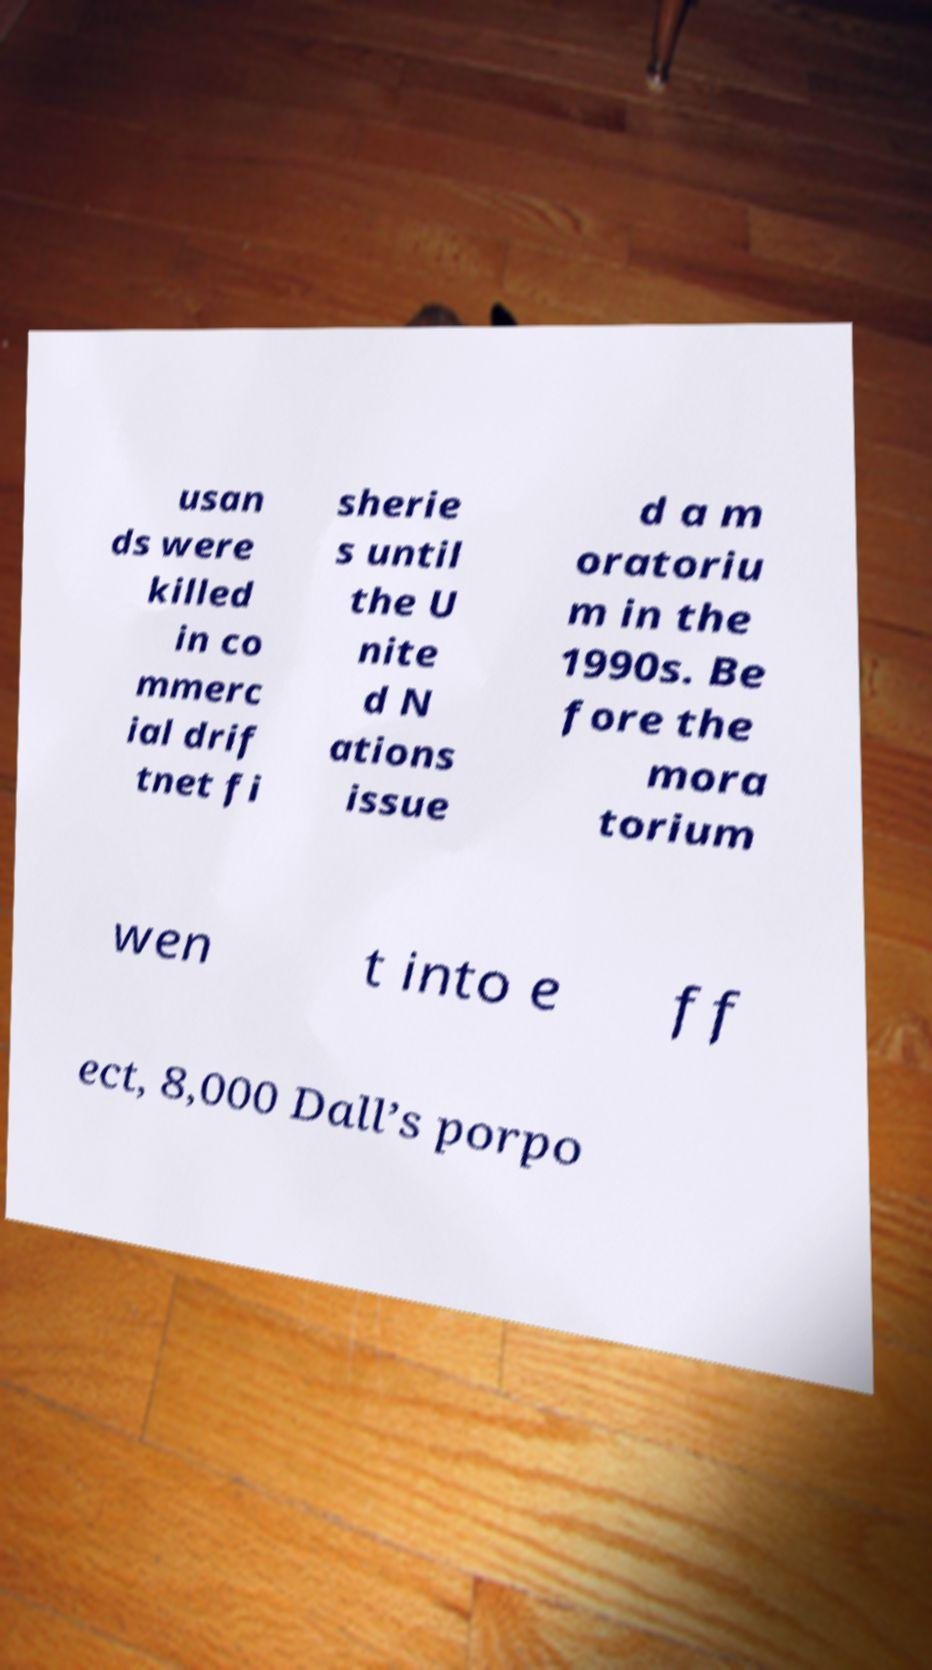Please identify and transcribe the text found in this image. usan ds were killed in co mmerc ial drif tnet fi sherie s until the U nite d N ations issue d a m oratoriu m in the 1990s. Be fore the mora torium wen t into e ff ect, 8,000 Dall’s porpo 